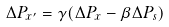Convert formula to latex. <formula><loc_0><loc_0><loc_500><loc_500>\Delta P _ { x ^ { \prime } } = \gamma ( \Delta P _ { x } - \beta \Delta P _ { s } )</formula> 